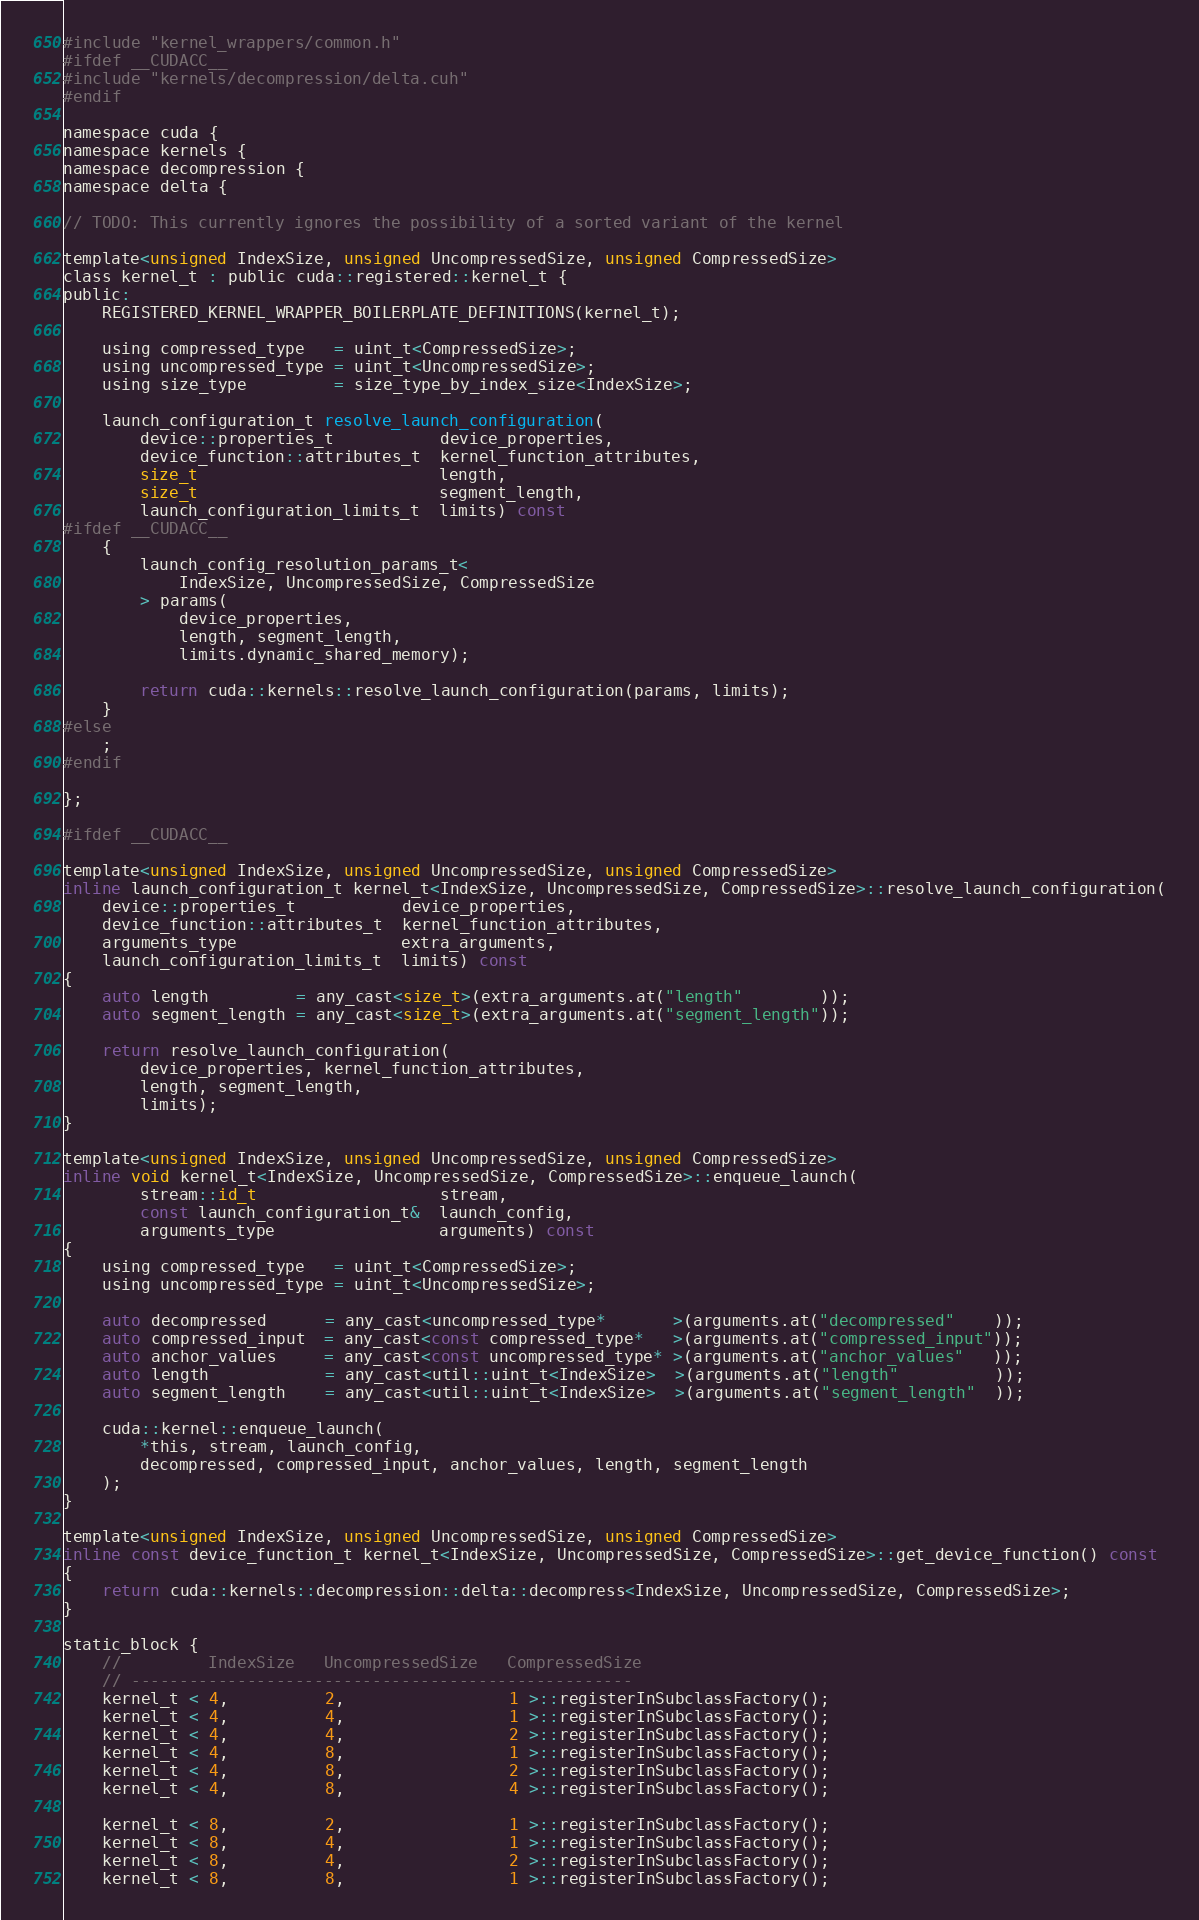Convert code to text. <code><loc_0><loc_0><loc_500><loc_500><_Cuda_>
#include "kernel_wrappers/common.h"
#ifdef __CUDACC__
#include "kernels/decompression/delta.cuh"
#endif

namespace cuda {
namespace kernels {
namespace decompression {
namespace delta {

// TODO: This currently ignores the possibility of a sorted variant of the kernel

template<unsigned IndexSize, unsigned UncompressedSize, unsigned CompressedSize>
class kernel_t : public cuda::registered::kernel_t {
public:
	REGISTERED_KERNEL_WRAPPER_BOILERPLATE_DEFINITIONS(kernel_t);

	using compressed_type   = uint_t<CompressedSize>;
	using uncompressed_type = uint_t<UncompressedSize>;
	using size_type         = size_type_by_index_size<IndexSize>;

	launch_configuration_t resolve_launch_configuration(
		device::properties_t           device_properties,
		device_function::attributes_t  kernel_function_attributes,
		size_t                         length,
		size_t                         segment_length,
		launch_configuration_limits_t  limits) const
#ifdef __CUDACC__
	{
		launch_config_resolution_params_t<
			IndexSize, UncompressedSize, CompressedSize
		> params(
			device_properties,
			length, segment_length,
			limits.dynamic_shared_memory);

		return cuda::kernels::resolve_launch_configuration(params, limits);
	}
#else
	;
#endif

};

#ifdef __CUDACC__

template<unsigned IndexSize, unsigned UncompressedSize, unsigned CompressedSize>
inline launch_configuration_t kernel_t<IndexSize, UncompressedSize, CompressedSize>::resolve_launch_configuration(
	device::properties_t           device_properties,
	device_function::attributes_t  kernel_function_attributes,
	arguments_type                 extra_arguments,
	launch_configuration_limits_t  limits) const
{
	auto length         = any_cast<size_t>(extra_arguments.at("length"        ));
	auto segment_length = any_cast<size_t>(extra_arguments.at("segment_length"));

	return resolve_launch_configuration(
		device_properties, kernel_function_attributes,
		length, segment_length,
		limits);
}

template<unsigned IndexSize, unsigned UncompressedSize, unsigned CompressedSize>
inline void kernel_t<IndexSize, UncompressedSize, CompressedSize>::enqueue_launch(
		stream::id_t                   stream,
		const launch_configuration_t&  launch_config,
		arguments_type                 arguments) const
{
	using compressed_type   = uint_t<CompressedSize>;
	using uncompressed_type = uint_t<UncompressedSize>;

	auto decompressed      = any_cast<uncompressed_type*       >(arguments.at("decompressed"    ));
	auto compressed_input  = any_cast<const compressed_type*   >(arguments.at("compressed_input"));
	auto anchor_values     = any_cast<const uncompressed_type* >(arguments.at("anchor_values"   ));
	auto length            = any_cast<util::uint_t<IndexSize>  >(arguments.at("length"          ));
	auto segment_length    = any_cast<util::uint_t<IndexSize>  >(arguments.at("segment_length"  ));

	cuda::kernel::enqueue_launch(
		*this, stream, launch_config,
		decompressed, compressed_input, anchor_values, length, segment_length
	);
}

template<unsigned IndexSize, unsigned UncompressedSize, unsigned CompressedSize>
inline const device_function_t kernel_t<IndexSize, UncompressedSize, CompressedSize>::get_device_function() const
{
	return cuda::kernels::decompression::delta::decompress<IndexSize, UncompressedSize, CompressedSize>;
}

static_block {
	//         IndexSize   UncompressedSize   CompressedSize
	// ----------------------------------------------------
	kernel_t < 4,          2,                 1 >::registerInSubclassFactory();
	kernel_t < 4,          4,                 1 >::registerInSubclassFactory();
	kernel_t < 4,          4,                 2 >::registerInSubclassFactory();
	kernel_t < 4,          8,                 1 >::registerInSubclassFactory();
	kernel_t < 4,          8,                 2 >::registerInSubclassFactory();
	kernel_t < 4,          8,                 4 >::registerInSubclassFactory();

	kernel_t < 8,          2,                 1 >::registerInSubclassFactory();
	kernel_t < 8,          4,                 1 >::registerInSubclassFactory();
	kernel_t < 8,          4,                 2 >::registerInSubclassFactory();
	kernel_t < 8,          8,                 1 >::registerInSubclassFactory();</code> 